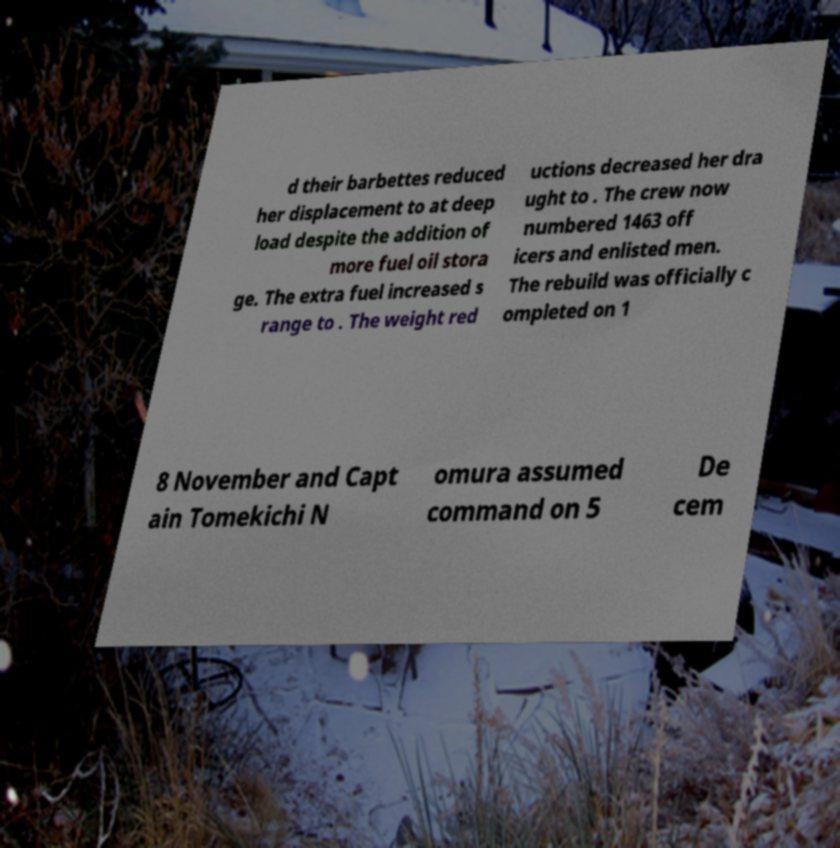What messages or text are displayed in this image? I need them in a readable, typed format. d their barbettes reduced her displacement to at deep load despite the addition of more fuel oil stora ge. The extra fuel increased s range to . The weight red uctions decreased her dra ught to . The crew now numbered 1463 off icers and enlisted men. The rebuild was officially c ompleted on 1 8 November and Capt ain Tomekichi N omura assumed command on 5 De cem 